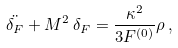<formula> <loc_0><loc_0><loc_500><loc_500>\ddot { \delta _ { F } } + M ^ { 2 } \, \delta _ { F } = \frac { \kappa ^ { 2 } } { 3 F ^ { ( 0 ) } } \rho \, ,</formula> 